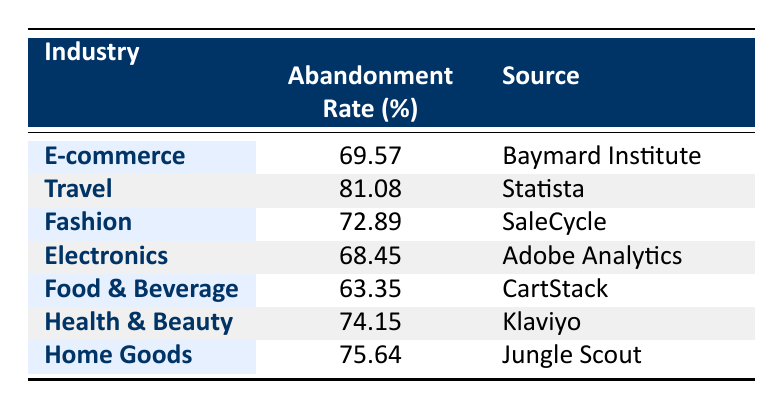What is the abandonment rate for the Travel industry? The table lists the abandonment rates for different industries, and the rate for Travel is specifically mentioned as 81.08%.
Answer: 81.08 Which industry has the lowest cart abandonment rate? By examining the rates in the table, Food & Beverage has the lowest abandonment rate at 63.35%.
Answer: 63.35 What is the average cart abandonment rate across the listed industries? To find the average, we add up all the abandonment rates (69.57 + 81.08 + 72.89 + 68.45 + 63.35 + 74.15 + 75.64) which equals 505.13, and divide by the number of industries (7), giving us an average of 72.16%.
Answer: 72.16 Is the abandonment rate for Home Goods higher than that for Electronics? The rate for Home Goods is 75.64%, while Electronics has a rate of 68.45%. Since 75.64 is greater than 68.45, the answer is yes.
Answer: Yes What is the difference in cart abandonment rates between the Travel and Food & Beverage industries? The table shows a 81.08% abandonment rate for Travel and 63.35% for Food & Beverage. To find the difference, we subtract Food & Beverage's rate from Travel's rate: 81.08 - 63.35 = 17.73%.
Answer: 17.73 How many industries have a cart abandonment rate of over 70%? A review of the table reveals that E-commerce (69.57), Travel (81.08), Fashion (72.89), Health & Beauty (74.15), and Home Goods (75.64) each exceed 70%. In total, there are 5 such industries.
Answer: 5 Is the cart abandonment rate in the Fashion industry more than 70%? The rate for Fashion is directly listed at 72.89%, which is indeed more than 70%.
Answer: Yes What are the sources for the abandonment rates of the Fashion and Home Goods industries? The table displays the source for Fashion as SaleCycle and for Home Goods as Jungle Scout.
Answer: SaleCycle and Jungle Scout 